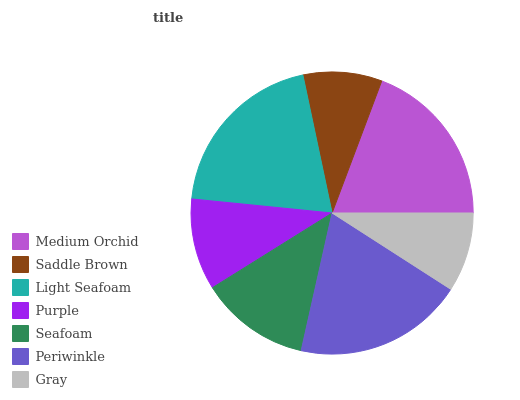Is Saddle Brown the minimum?
Answer yes or no. Yes. Is Light Seafoam the maximum?
Answer yes or no. Yes. Is Light Seafoam the minimum?
Answer yes or no. No. Is Saddle Brown the maximum?
Answer yes or no. No. Is Light Seafoam greater than Saddle Brown?
Answer yes or no. Yes. Is Saddle Brown less than Light Seafoam?
Answer yes or no. Yes. Is Saddle Brown greater than Light Seafoam?
Answer yes or no. No. Is Light Seafoam less than Saddle Brown?
Answer yes or no. No. Is Seafoam the high median?
Answer yes or no. Yes. Is Seafoam the low median?
Answer yes or no. Yes. Is Gray the high median?
Answer yes or no. No. Is Light Seafoam the low median?
Answer yes or no. No. 